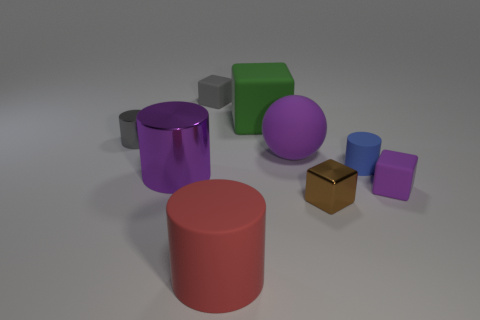Are there fewer large matte cubes than blocks?
Provide a short and direct response. Yes. The large metal thing that is the same shape as the red rubber object is what color?
Offer a terse response. Purple. Are there any other things that are the same shape as the big purple shiny object?
Your response must be concise. Yes. Are there more purple rubber blocks than small shiny things?
Offer a terse response. No. How many other things are made of the same material as the gray cylinder?
Ensure brevity in your answer.  2. What shape is the shiny thing on the right side of the rubber thing left of the rubber cylinder that is left of the big green cube?
Offer a terse response. Cube. Is the number of large matte blocks that are in front of the big purple shiny thing less than the number of tiny cylinders on the left side of the big green matte block?
Ensure brevity in your answer.  Yes. Are there any other balls of the same color as the sphere?
Provide a short and direct response. No. Are the tiny purple cube and the cylinder that is on the right side of the large red matte cylinder made of the same material?
Your answer should be very brief. Yes. There is a big purple object behind the large purple metal cylinder; is there a tiny metal cube behind it?
Offer a terse response. No. 